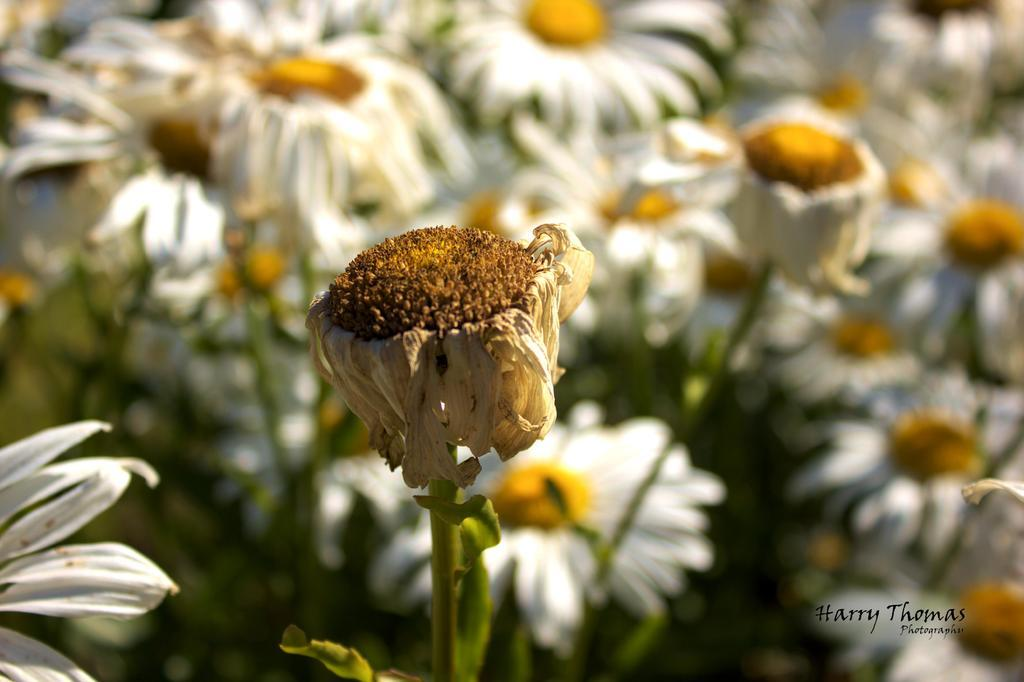What type of plants are in the image? The plants in the image have white sunflowers. What color are the sunflowers on the plants? The sunflowers on the plants are white. Is there any text or marking in the image? Yes, there is a watermark in the bottom right corner of the image. How would you describe the background of the image? The background of the image is blurred. How many hens can be seen in the image? There are no hens present in the image. What type of can is visible in the image? There is no can present in the image. 